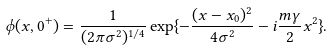Convert formula to latex. <formula><loc_0><loc_0><loc_500><loc_500>\phi ( x , 0 ^ { + } ) = \frac { 1 } { ( 2 \pi \sigma ^ { 2 } ) ^ { 1 / 4 } } \exp \{ - \frac { ( x - x _ { 0 } ) ^ { 2 } } { 4 \sigma ^ { 2 } } - i \frac { m \gamma } { 2 } x ^ { 2 } \} .</formula> 